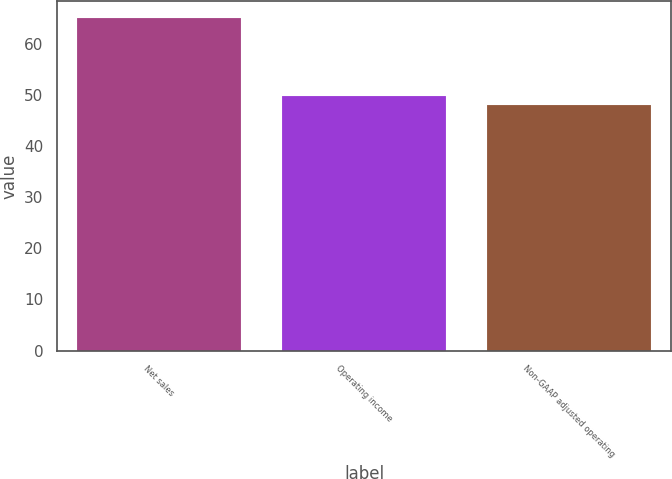Convert chart to OTSL. <chart><loc_0><loc_0><loc_500><loc_500><bar_chart><fcel>Net sales<fcel>Operating income<fcel>Non-GAAP adjusted operating<nl><fcel>65<fcel>49.7<fcel>48<nl></chart> 